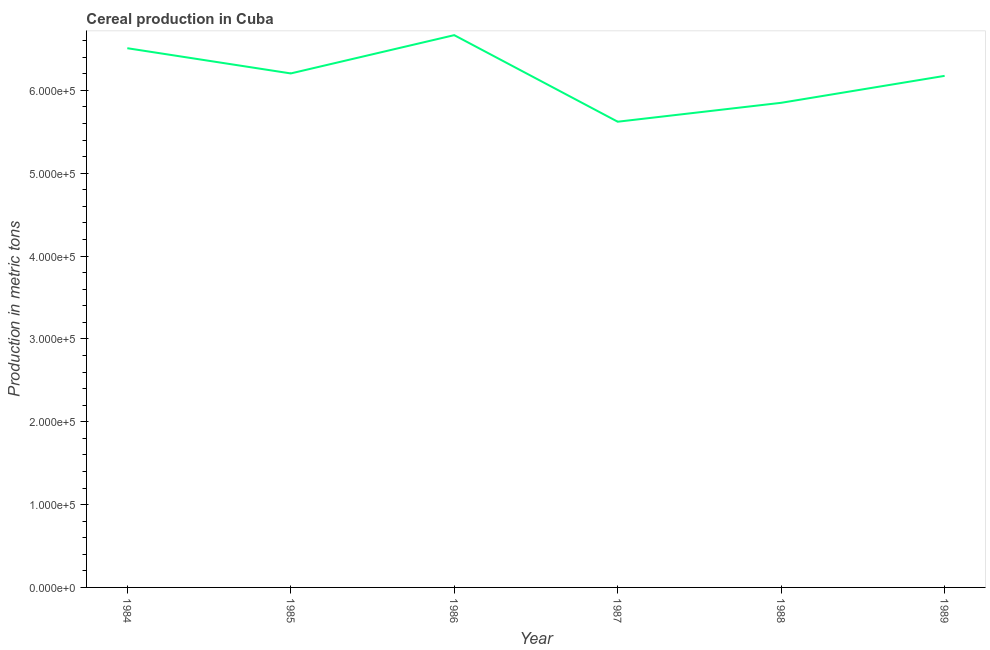What is the cereal production in 1988?
Provide a succinct answer. 5.85e+05. Across all years, what is the maximum cereal production?
Give a very brief answer. 6.67e+05. Across all years, what is the minimum cereal production?
Provide a succinct answer. 5.62e+05. What is the sum of the cereal production?
Make the answer very short. 3.70e+06. What is the difference between the cereal production in 1985 and 1986?
Keep it short and to the point. -4.62e+04. What is the average cereal production per year?
Make the answer very short. 6.17e+05. What is the median cereal production?
Provide a short and direct response. 6.19e+05. Do a majority of the years between 1989 and 1984 (inclusive) have cereal production greater than 140000 metric tons?
Make the answer very short. Yes. What is the ratio of the cereal production in 1987 to that in 1989?
Provide a short and direct response. 0.91. Is the cereal production in 1985 less than that in 1989?
Your answer should be very brief. No. Is the difference between the cereal production in 1988 and 1989 greater than the difference between any two years?
Your answer should be compact. No. What is the difference between the highest and the second highest cereal production?
Provide a succinct answer. 1.58e+04. What is the difference between the highest and the lowest cereal production?
Your answer should be very brief. 1.04e+05. In how many years, is the cereal production greater than the average cereal production taken over all years?
Provide a short and direct response. 4. Does the cereal production monotonically increase over the years?
Your answer should be compact. No. Does the graph contain any zero values?
Keep it short and to the point. No. What is the title of the graph?
Give a very brief answer. Cereal production in Cuba. What is the label or title of the X-axis?
Your response must be concise. Year. What is the label or title of the Y-axis?
Make the answer very short. Production in metric tons. What is the Production in metric tons in 1984?
Your response must be concise. 6.51e+05. What is the Production in metric tons of 1985?
Offer a terse response. 6.20e+05. What is the Production in metric tons in 1986?
Your response must be concise. 6.67e+05. What is the Production in metric tons of 1987?
Keep it short and to the point. 5.62e+05. What is the Production in metric tons in 1988?
Keep it short and to the point. 5.85e+05. What is the Production in metric tons of 1989?
Your answer should be very brief. 6.17e+05. What is the difference between the Production in metric tons in 1984 and 1985?
Your answer should be compact. 3.04e+04. What is the difference between the Production in metric tons in 1984 and 1986?
Your answer should be compact. -1.58e+04. What is the difference between the Production in metric tons in 1984 and 1987?
Provide a succinct answer. 8.87e+04. What is the difference between the Production in metric tons in 1984 and 1988?
Your answer should be very brief. 6.59e+04. What is the difference between the Production in metric tons in 1984 and 1989?
Your answer should be compact. 3.34e+04. What is the difference between the Production in metric tons in 1985 and 1986?
Your answer should be compact. -4.62e+04. What is the difference between the Production in metric tons in 1985 and 1987?
Your answer should be compact. 5.83e+04. What is the difference between the Production in metric tons in 1985 and 1988?
Your answer should be very brief. 3.55e+04. What is the difference between the Production in metric tons in 1985 and 1989?
Your response must be concise. 2939. What is the difference between the Production in metric tons in 1986 and 1987?
Your answer should be compact. 1.04e+05. What is the difference between the Production in metric tons in 1986 and 1988?
Your response must be concise. 8.17e+04. What is the difference between the Production in metric tons in 1986 and 1989?
Make the answer very short. 4.91e+04. What is the difference between the Production in metric tons in 1987 and 1988?
Provide a succinct answer. -2.28e+04. What is the difference between the Production in metric tons in 1987 and 1989?
Your answer should be compact. -5.53e+04. What is the difference between the Production in metric tons in 1988 and 1989?
Your answer should be very brief. -3.25e+04. What is the ratio of the Production in metric tons in 1984 to that in 1985?
Provide a succinct answer. 1.05. What is the ratio of the Production in metric tons in 1984 to that in 1986?
Give a very brief answer. 0.98. What is the ratio of the Production in metric tons in 1984 to that in 1987?
Your answer should be compact. 1.16. What is the ratio of the Production in metric tons in 1984 to that in 1988?
Ensure brevity in your answer.  1.11. What is the ratio of the Production in metric tons in 1984 to that in 1989?
Keep it short and to the point. 1.05. What is the ratio of the Production in metric tons in 1985 to that in 1986?
Provide a succinct answer. 0.93. What is the ratio of the Production in metric tons in 1985 to that in 1987?
Your answer should be very brief. 1.1. What is the ratio of the Production in metric tons in 1985 to that in 1988?
Keep it short and to the point. 1.06. What is the ratio of the Production in metric tons in 1985 to that in 1989?
Ensure brevity in your answer.  1. What is the ratio of the Production in metric tons in 1986 to that in 1987?
Your answer should be compact. 1.19. What is the ratio of the Production in metric tons in 1986 to that in 1988?
Give a very brief answer. 1.14. What is the ratio of the Production in metric tons in 1987 to that in 1988?
Provide a succinct answer. 0.96. What is the ratio of the Production in metric tons in 1987 to that in 1989?
Provide a succinct answer. 0.91. What is the ratio of the Production in metric tons in 1988 to that in 1989?
Ensure brevity in your answer.  0.95. 